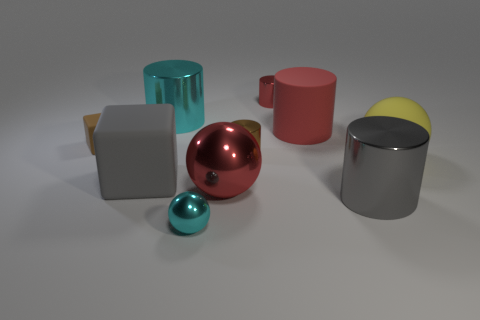Subtract all brown cylinders. How many cylinders are left? 4 Subtract all large cyan cylinders. How many cylinders are left? 4 Subtract all blue cylinders. Subtract all gray blocks. How many cylinders are left? 5 Subtract all spheres. How many objects are left? 7 Add 1 big matte cylinders. How many big matte cylinders are left? 2 Add 7 large cylinders. How many large cylinders exist? 10 Subtract 0 red blocks. How many objects are left? 10 Subtract all red balls. Subtract all large cubes. How many objects are left? 8 